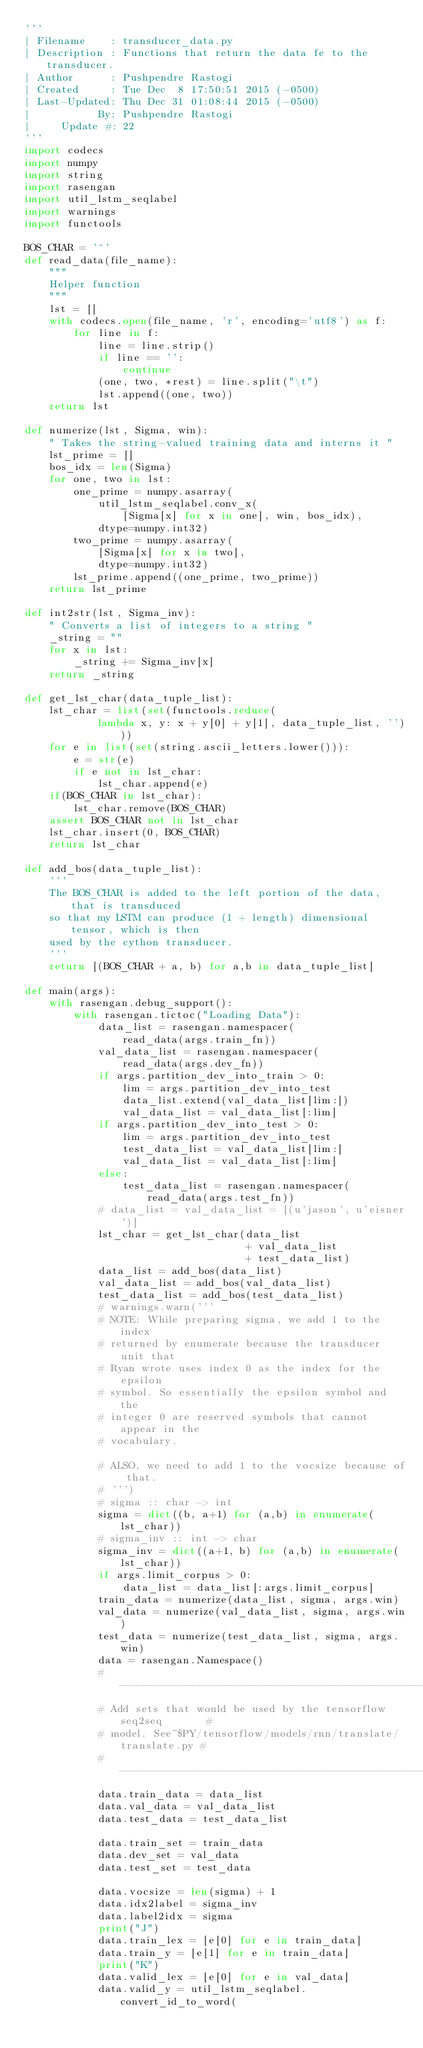Convert code to text. <code><loc_0><loc_0><loc_500><loc_500><_Python_>'''
| Filename    : transducer_data.py
| Description : Functions that return the data fe to the transducer.
| Author      : Pushpendre Rastogi
| Created     : Tue Dec  8 17:50:51 2015 (-0500)
| Last-Updated: Thu Dec 31 01:08:44 2015 (-0500)
|           By: Pushpendre Rastogi
|     Update #: 22
'''
import codecs
import numpy
import string
import rasengan
import util_lstm_seqlabel
import warnings
import functools

BOS_CHAR = '^'
def read_data(file_name):
    """
    Helper function
    """
    lst = []
    with codecs.open(file_name, 'r', encoding='utf8') as f:
        for line in f:
            line = line.strip()
            if line == '':
                continue
            (one, two, *rest) = line.split("\t")
            lst.append((one, two))
    return lst

def numerize(lst, Sigma, win):
    " Takes the string-valued training data and interns it "
    lst_prime = []
    bos_idx = len(Sigma)
    for one, two in lst:
        one_prime = numpy.asarray(
            util_lstm_seqlabel.conv_x(
                [Sigma[x] for x in one], win, bos_idx),
            dtype=numpy.int32)
        two_prime = numpy.asarray(
            [Sigma[x] for x in two],
            dtype=numpy.int32)
        lst_prime.append((one_prime, two_prime))
    return lst_prime

def int2str(lst, Sigma_inv):
    " Converts a list of integers to a string "
    _string = ""
    for x in lst:
        _string += Sigma_inv[x]
    return _string

def get_lst_char(data_tuple_list):
    lst_char = list(set(functools.reduce(
            lambda x, y: x + y[0] + y[1], data_tuple_list, '')))
    for e in list(set(string.ascii_letters.lower())):
        e = str(e)
        if e not in lst_char:
            lst_char.append(e)
    if(BOS_CHAR in lst_char):
        lst_char.remove(BOS_CHAR)
    assert BOS_CHAR not in lst_char
    lst_char.insert(0, BOS_CHAR)
    return lst_char

def add_bos(data_tuple_list):
    '''
    The BOS_CHAR is added to the left portion of the data, that is transduced
    so that my LSTM can produce (1 + length) dimensional tensor, which is then
    used by the cython transducer.
    '''
    return [(BOS_CHAR + a, b) for a,b in data_tuple_list]

def main(args):
    with rasengan.debug_support():
        with rasengan.tictoc("Loading Data"):
            data_list = rasengan.namespacer(
                read_data(args.train_fn))
            val_data_list = rasengan.namespacer(
                read_data(args.dev_fn))
            if args.partition_dev_into_train > 0:
                lim = args.partition_dev_into_test
                data_list.extend(val_data_list[lim:])
                val_data_list = val_data_list[:lim]
            if args.partition_dev_into_test > 0:
                lim = args.partition_dev_into_test
                test_data_list = val_data_list[lim:]
                val_data_list = val_data_list[:lim]
            else:
                test_data_list = rasengan.namespacer(
                    read_data(args.test_fn))
            # data_list = val_data_list = [(u'jason', u'eisner')]
            lst_char = get_lst_char(data_list
                                    + val_data_list
                                    + test_data_list)
            data_list = add_bos(data_list)
            val_data_list = add_bos(val_data_list)
            test_data_list = add_bos(test_data_list)
            # warnings.warn('''
            # NOTE: While preparing sigma, we add 1 to the index
            # returned by enumerate because the transducer unit that
            # Ryan wrote uses index 0 as the index for the epsilon
            # symbol. So essentially the epsilon symbol and the
            # integer 0 are reserved symbols that cannot appear in the
            # vocabulary.

            # ALSO, we need to add 1 to the vocsize because of that.
            # ''')
            # sigma :: char -> int
            sigma = dict((b, a+1) for (a,b) in enumerate(lst_char))
            # sigma_inv :: int -> char
            sigma_inv = dict((a+1, b) for (a,b) in enumerate(lst_char))
            if args.limit_corpus > 0:
                data_list = data_list[:args.limit_corpus]
            train_data = numerize(data_list, sigma, args.win)
            val_data = numerize(val_data_list, sigma, args.win)
            test_data = numerize(test_data_list, sigma, args.win)
            data = rasengan.Namespace()
            #-------------------------------------------------------------#
            # Add sets that would be used by the tensorflow seq2seq       #
            # model. See~$PY/tensorflow/models/rnn/translate/translate.py #
            #-------------------------------------------------------------#
            data.train_data = data_list
            data.val_data = val_data_list
            data.test_data = test_data_list

            data.train_set = train_data
            data.dev_set = val_data
            data.test_set = test_data

            data.vocsize = len(sigma) + 1
            data.idx2label = sigma_inv
            data.label2idx = sigma
            print("J")
            data.train_lex = [e[0] for e in train_data]
            data.train_y = [e[1] for e in train_data]
            print("K")
            data.valid_lex = [e[0] for e in val_data]
            data.valid_y = util_lstm_seqlabel.convert_id_to_word(</code> 